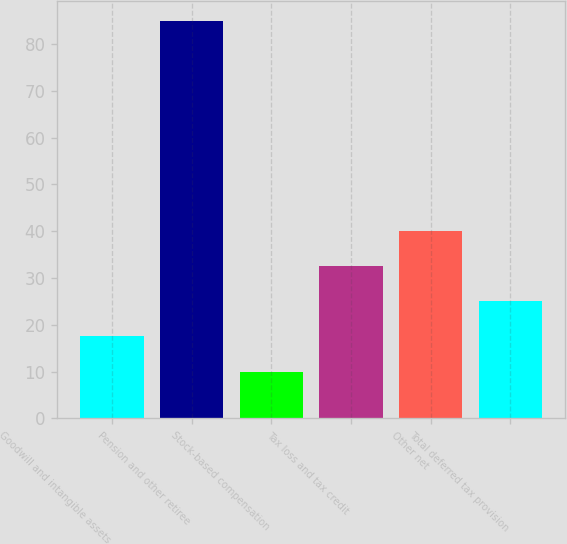Convert chart. <chart><loc_0><loc_0><loc_500><loc_500><bar_chart><fcel>Goodwill and intangible assets<fcel>Pension and other retiree<fcel>Stock-based compensation<fcel>Tax loss and tax credit<fcel>Other net<fcel>Total deferred tax provision<nl><fcel>17.5<fcel>85<fcel>10<fcel>32.5<fcel>40<fcel>25<nl></chart> 